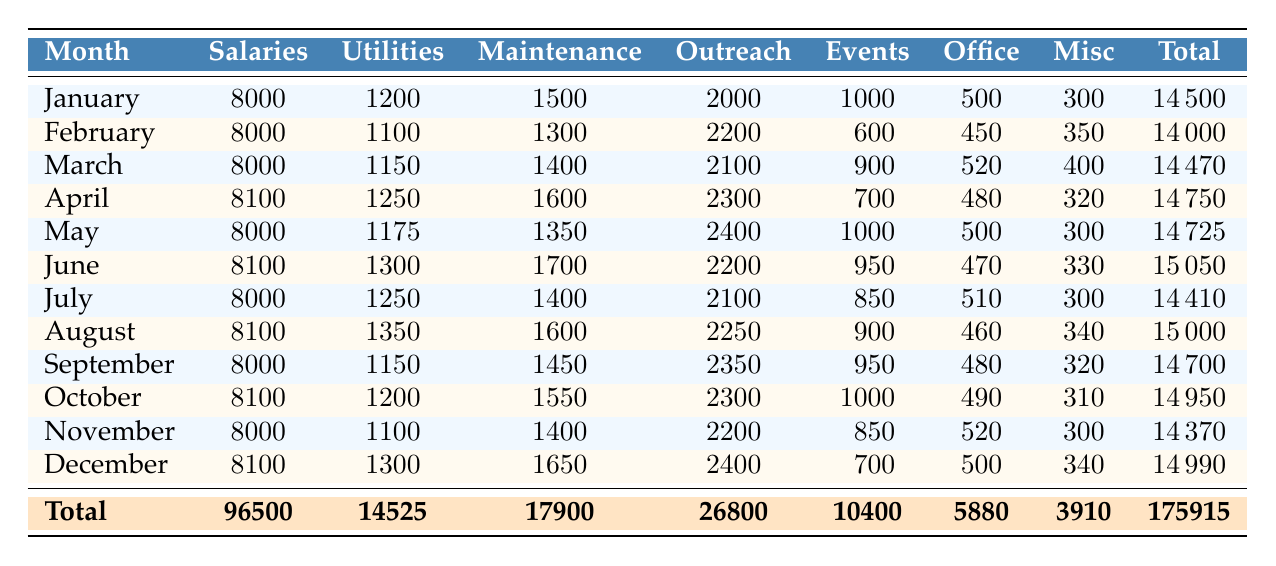What was the total amount spent on Maintenance and Repairs throughout 2021? To find the total amount spent on Maintenance and Repairs, we sum the values from each month: 1500 + 1300 + 1400 + 1600 + 1350 + 1700 + 1400 + 1600 + 1450 + 1550 + 1400 + 1650 = 17900.
Answer: 17900 In which month did the church spend the most on Utilities? Comparing the Utilities expenses for each month, January had 1200, February had 1100, March had 1150, April had 1250, May had 1175, June had 1300, July had 1250, August had 1350, September had 1150, October had 1200, November had 1100, and December had 1300. The highest value is August with 1350.
Answer: August Was the total spending on Outreach Programs greater than 25000 for the year? The total for Outreach Programs is calculated as follows: 2000 + 2200 + 2100 + 2300 + 2400 + 2200 + 2100 + 2250 + 2350 + 2300 + 2200 + 2400 = 26800, which is greater than 25000.
Answer: Yes What is the average amount spent on Office Supplies each month? We take the sum of Office Supplies amounts: 500 + 450 + 520 + 480 + 500 + 470 + 510 + 460 + 480 + 490 + 520 + 500 = 5880. There are 12 months, so we divide 5880 by 12 to get an average of 490.
Answer: 490 In which month did the church have the lowest total expenses? We need to calculate the total expenses for each month by adding all expense categories together. The totals are as follows: January 14500, February 14000, March 14470, April 14750, May 14725, June 15050, July 14410, August 15000, September 14700, October 14950, November 14370, and December 14990. The lowest total is February with 14000.
Answer: February 